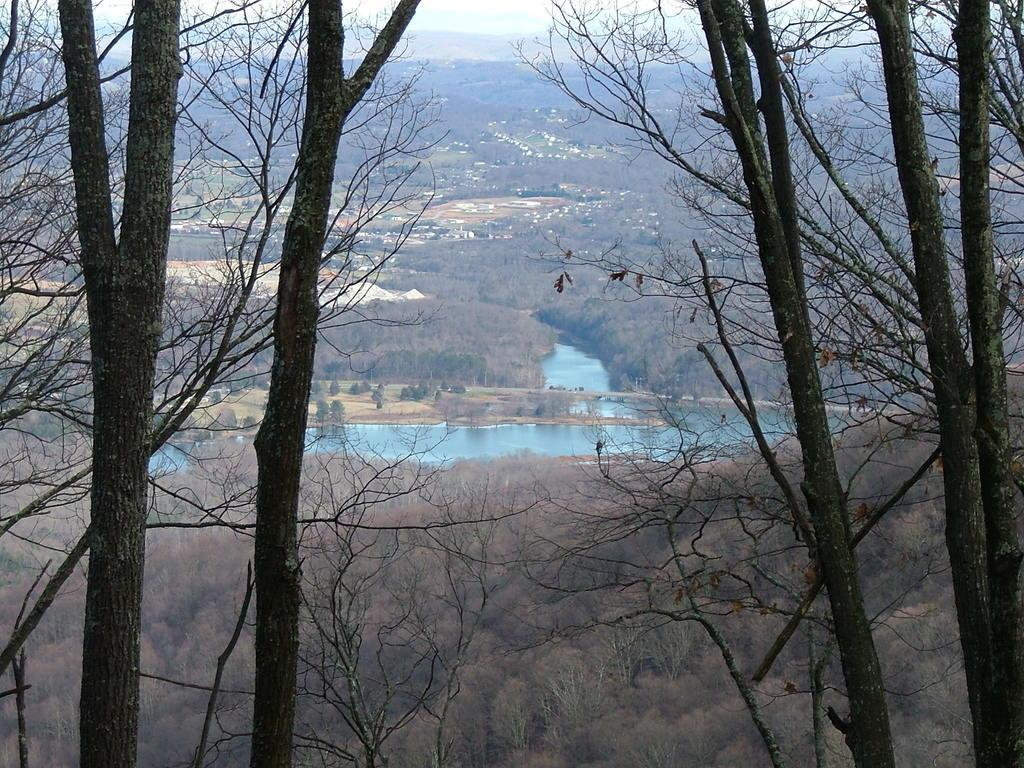What is the vantage point of the image? The image is taken from the top of a mountain. What type of natural environment can be seen in the image? There are many trees and water visible in the image. What type of geographical features can be seen in the image? There are mountains visible in the image. Are there any signs of human habitation in the image? Yes, there are houses visible in the image. What historical event is being commemorated in the image? There is no indication of a historical event being commemorated in the image. What type of comfort can be found in the houses visible in the image? The image does not provide information about the comfort or condition of the houses. 